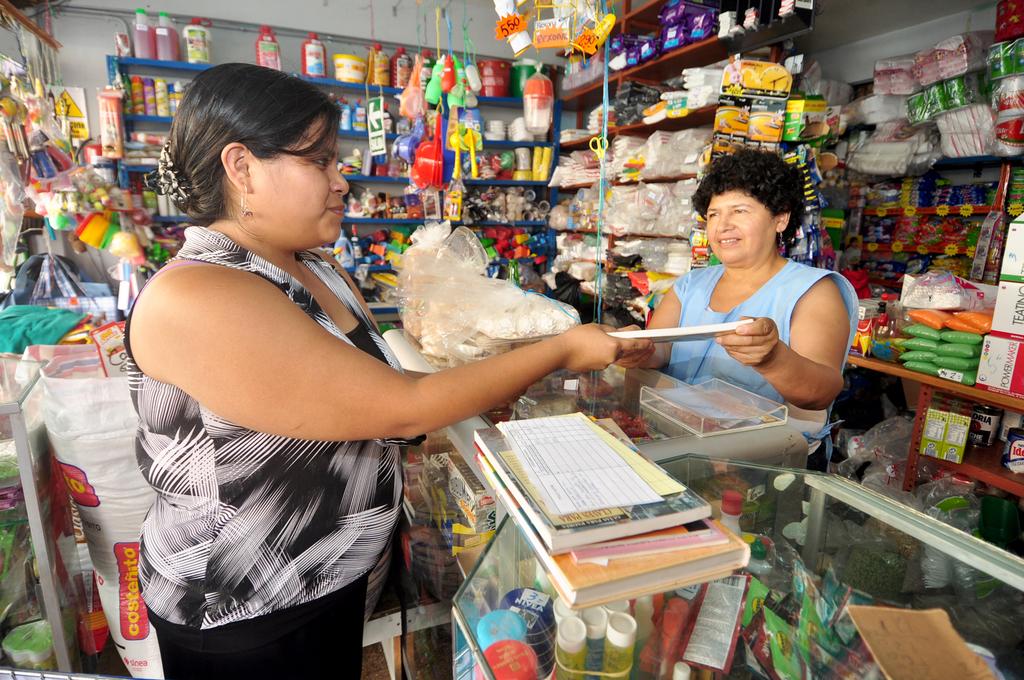What is written on the white bag behind the lady?
Offer a terse response. Costenito. 